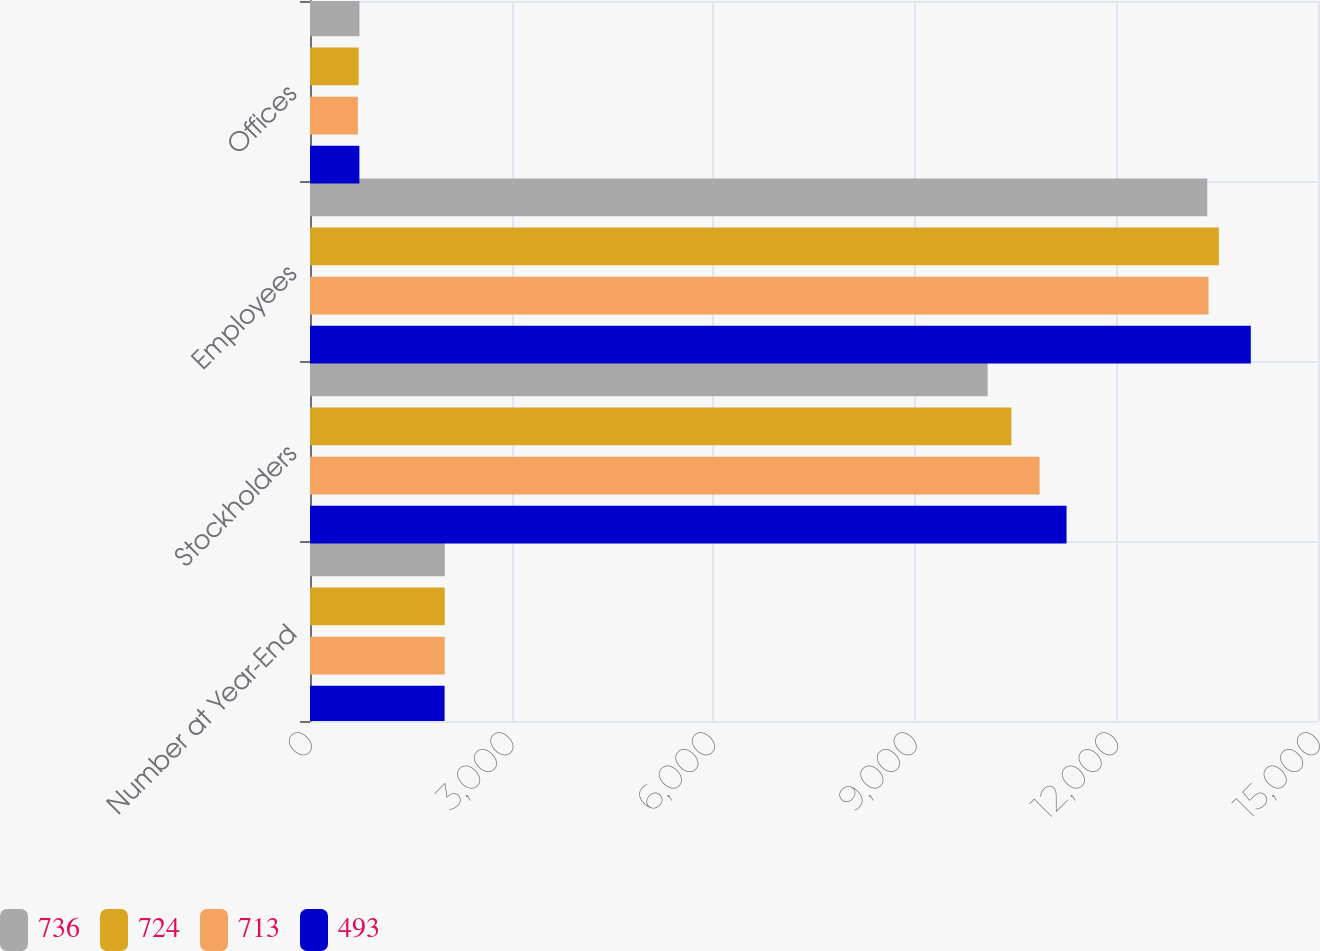Convert chart. <chart><loc_0><loc_0><loc_500><loc_500><stacked_bar_chart><ecel><fcel>Number at Year-End<fcel>Stockholders<fcel>Employees<fcel>Offices<nl><fcel>736<fcel>2006<fcel>10084<fcel>13352<fcel>736<nl><fcel>724<fcel>2005<fcel>10437<fcel>13525<fcel>724<nl><fcel>713<fcel>2004<fcel>10857<fcel>13371<fcel>713<nl><fcel>493<fcel>2003<fcel>11258<fcel>14000<fcel>735<nl></chart> 